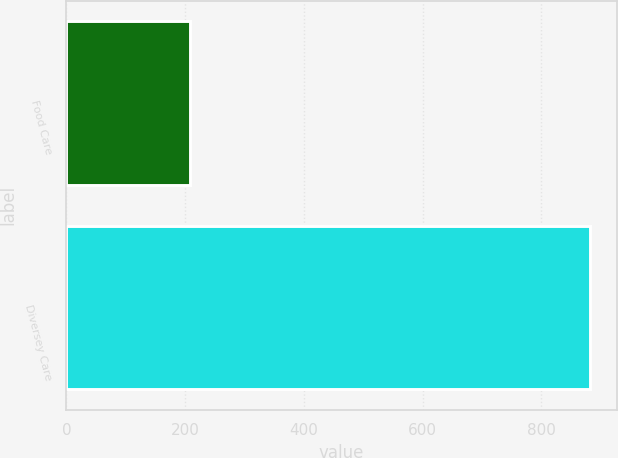Convert chart. <chart><loc_0><loc_0><loc_500><loc_500><bar_chart><fcel>Food Care<fcel>Diversey Care<nl><fcel>208<fcel>883<nl></chart> 